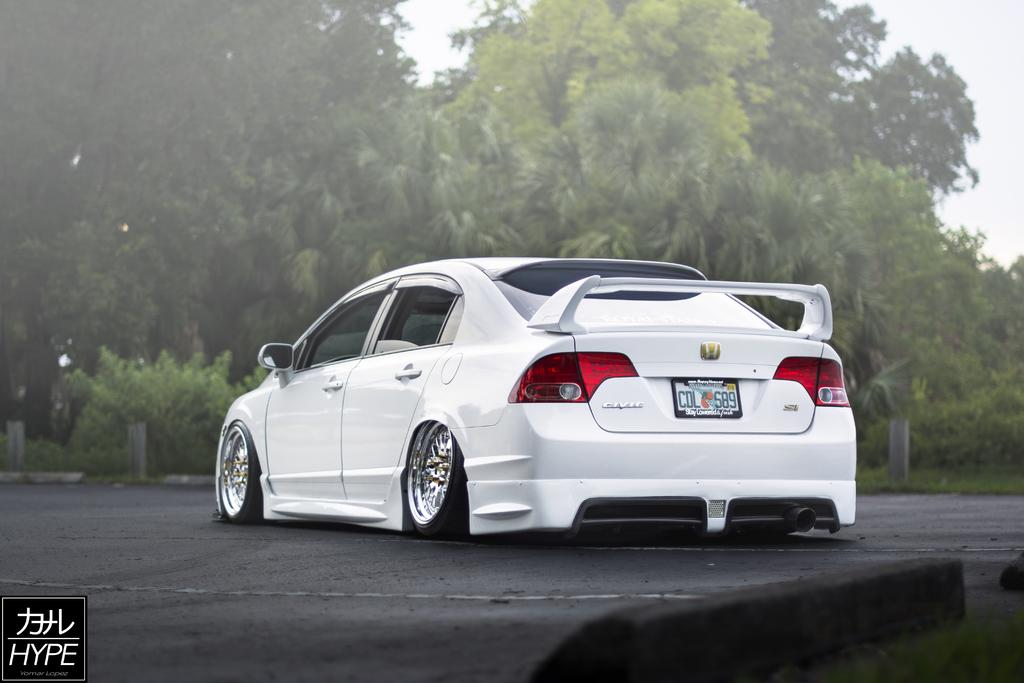What is the main subject of the image? The main subject of the image is a car on the road. What other elements can be seen in the image? There are plants, trees, and the sky visible in the image. What type of grass is growing in the town shown in the image? There is no town present in the image, and therefore no grass can be observed. 